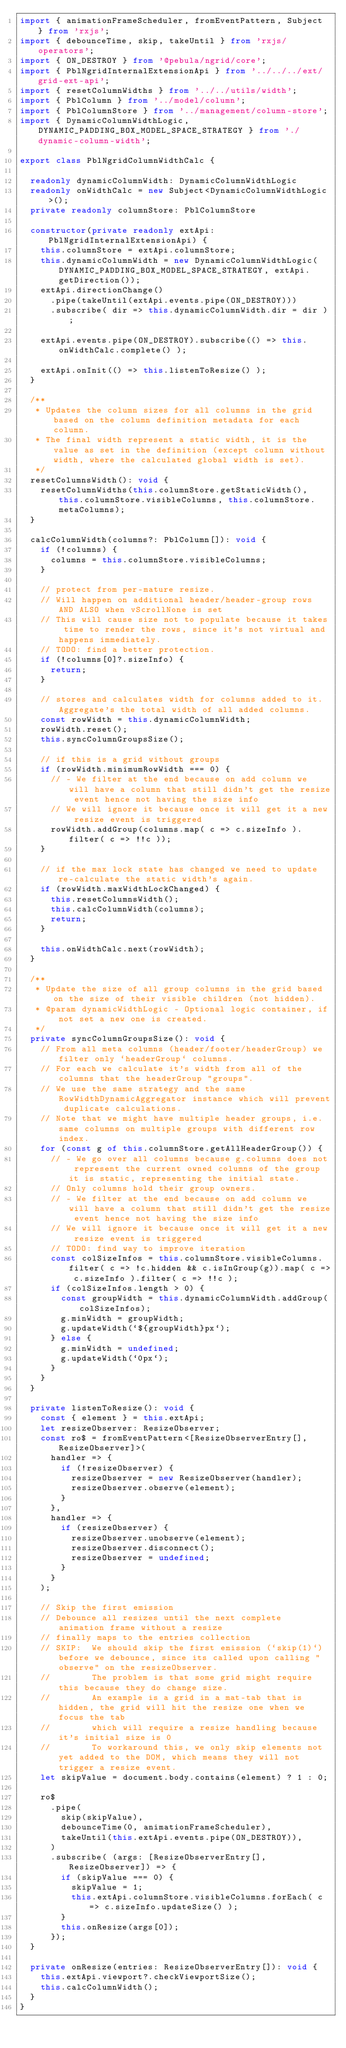Convert code to text. <code><loc_0><loc_0><loc_500><loc_500><_TypeScript_>import { animationFrameScheduler, fromEventPattern, Subject } from 'rxjs';
import { debounceTime, skip, takeUntil } from 'rxjs/operators';
import { ON_DESTROY } from '@pebula/ngrid/core';
import { PblNgridInternalExtensionApi } from '../../../ext/grid-ext-api';
import { resetColumnWidths } from '../../utils/width';
import { PblColumn } from '../model/column';
import { PblColumnStore } from '../management/column-store';
import { DynamicColumnWidthLogic, DYNAMIC_PADDING_BOX_MODEL_SPACE_STRATEGY } from './dynamic-column-width';

export class PblNgridColumnWidthCalc {

  readonly dynamicColumnWidth: DynamicColumnWidthLogic
  readonly onWidthCalc = new Subject<DynamicColumnWidthLogic>();
  private readonly columnStore: PblColumnStore

  constructor(private readonly extApi: PblNgridInternalExtensionApi) {
    this.columnStore = extApi.columnStore;
    this.dynamicColumnWidth = new DynamicColumnWidthLogic(DYNAMIC_PADDING_BOX_MODEL_SPACE_STRATEGY, extApi.getDirection());
    extApi.directionChange()
      .pipe(takeUntil(extApi.events.pipe(ON_DESTROY)))
      .subscribe( dir => this.dynamicColumnWidth.dir = dir );

    extApi.events.pipe(ON_DESTROY).subscribe(() => this.onWidthCalc.complete() );

    extApi.onInit(() => this.listenToResize() );
  }

  /**
   * Updates the column sizes for all columns in the grid based on the column definition metadata for each column.
   * The final width represent a static width, it is the value as set in the definition (except column without width, where the calculated global width is set).
   */
  resetColumnsWidth(): void {
    resetColumnWidths(this.columnStore.getStaticWidth(), this.columnStore.visibleColumns, this.columnStore.metaColumns);
  }

  calcColumnWidth(columns?: PblColumn[]): void {
    if (!columns) {
      columns = this.columnStore.visibleColumns;
    }

    // protect from per-mature resize.
    // Will happen on additional header/header-group rows AND ALSO when vScrollNone is set
    // This will cause size not to populate because it takes time to render the rows, since it's not virtual and happens immediately.
    // TODO: find a better protection.
    if (!columns[0]?.sizeInfo) {
      return;
    }

    // stores and calculates width for columns added to it. Aggregate's the total width of all added columns.
    const rowWidth = this.dynamicColumnWidth;
    rowWidth.reset();
    this.syncColumnGroupsSize();

    // if this is a grid without groups
    if (rowWidth.minimumRowWidth === 0) {
      // - We filter at the end because on add column we will have a column that still didn't get the resize event hence not having the size info
      // We will ignore it because once it will get it a new resize event is triggered
      rowWidth.addGroup(columns.map( c => c.sizeInfo ).filter( c => !!c ));
    }

    // if the max lock state has changed we need to update re-calculate the static width's again.
    if (rowWidth.maxWidthLockChanged) {
      this.resetColumnsWidth();
      this.calcColumnWidth(columns);
      return;
    }

    this.onWidthCalc.next(rowWidth);
  }

  /**
   * Update the size of all group columns in the grid based on the size of their visible children (not hidden).
   * @param dynamicWidthLogic - Optional logic container, if not set a new one is created.
   */
  private syncColumnGroupsSize(): void {
    // From all meta columns (header/footer/headerGroup) we filter only `headerGroup` columns.
    // For each we calculate it's width from all of the columns that the headerGroup "groups".
    // We use the same strategy and the same RowWidthDynamicAggregator instance which will prevent duplicate calculations.
    // Note that we might have multiple header groups, i.e. same columns on multiple groups with different row index.
    for (const g of this.columnStore.getAllHeaderGroup()) {
      // - We go over all columns because g.columns does not represent the current owned columns of the group it is static, representing the initial state.
      // Only columns hold their group owners.
      // - We filter at the end because on add column we will have a column that still didn't get the resize event hence not having the size info
      // We will ignore it because once it will get it a new resize event is triggered
      // TODO: find way to improve iteration
      const colSizeInfos = this.columnStore.visibleColumns.filter( c => !c.hidden && c.isInGroup(g)).map( c => c.sizeInfo ).filter( c => !!c );
      if (colSizeInfos.length > 0) {
        const groupWidth = this.dynamicColumnWidth.addGroup(colSizeInfos);
        g.minWidth = groupWidth;
        g.updateWidth(`${groupWidth}px`);
      } else {
        g.minWidth = undefined;
        g.updateWidth(`0px`);
      }
    }
  }

  private listenToResize(): void {
    const { element } = this.extApi;
    let resizeObserver: ResizeObserver;
    const ro$ = fromEventPattern<[ResizeObserverEntry[], ResizeObserver]>(
      handler => {
        if (!resizeObserver) {
          resizeObserver = new ResizeObserver(handler);
          resizeObserver.observe(element);
        }
      },
      handler => {
        if (resizeObserver) {
          resizeObserver.unobserve(element);
          resizeObserver.disconnect();
          resizeObserver = undefined;
        }
      }
    );

    // Skip the first emission
    // Debounce all resizes until the next complete animation frame without a resize
    // finally maps to the entries collection
    // SKIP:  We should skip the first emission (`skip(1)`) before we debounce, since its called upon calling "observe" on the resizeObserver.
    //        The problem is that some grid might require this because they do change size.
    //        An example is a grid in a mat-tab that is hidden, the grid will hit the resize one when we focus the tab
    //        which will require a resize handling because it's initial size is 0
    //        To workaround this, we only skip elements not yet added to the DOM, which means they will not trigger a resize event.
    let skipValue = document.body.contains(element) ? 1 : 0;

    ro$
      .pipe(
        skip(skipValue),
        debounceTime(0, animationFrameScheduler),
        takeUntil(this.extApi.events.pipe(ON_DESTROY)),
      )
      .subscribe( (args: [ResizeObserverEntry[], ResizeObserver]) => {
        if (skipValue === 0) {
          skipValue = 1;
          this.extApi.columnStore.visibleColumns.forEach( c => c.sizeInfo.updateSize() );
        }
        this.onResize(args[0]);
      });
  }

  private onResize(entries: ResizeObserverEntry[]): void {
    this.extApi.viewport?.checkViewportSize();
    this.calcColumnWidth();
  }
}
</code> 